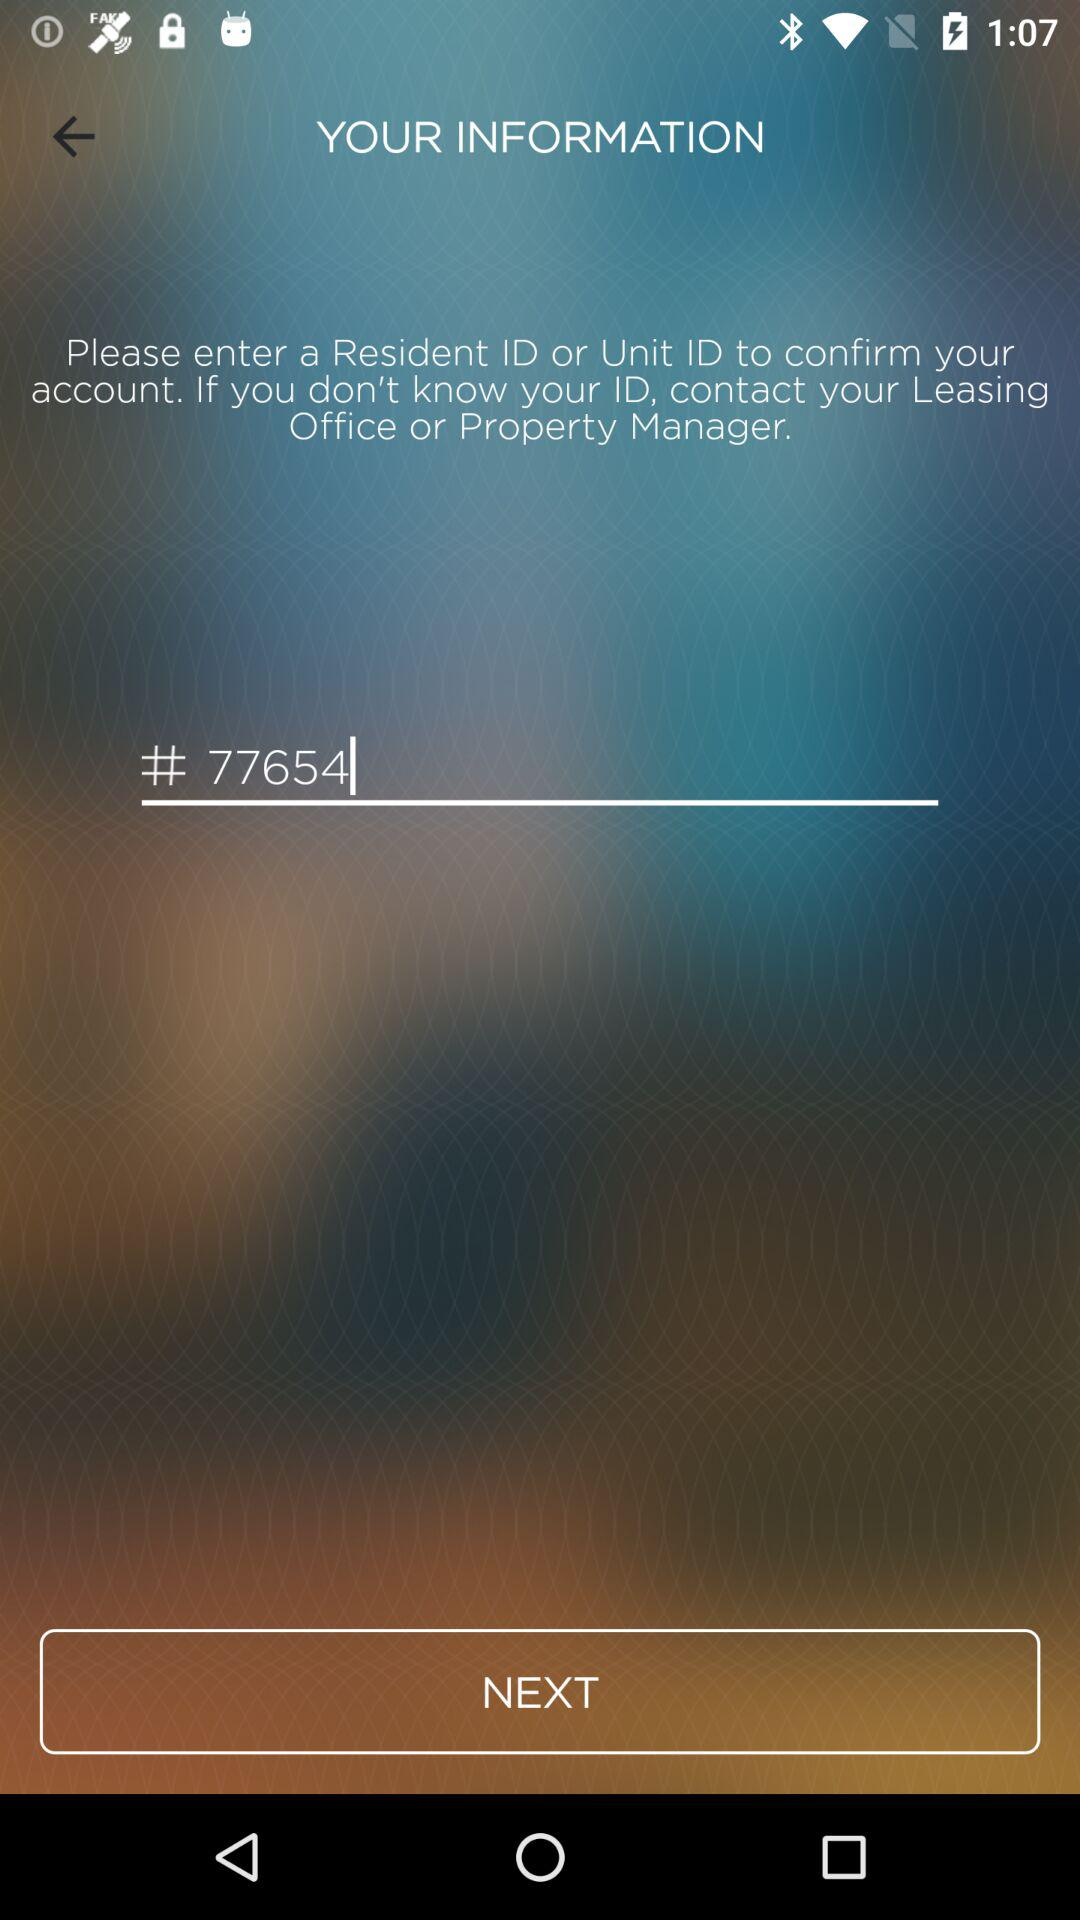What is the resident ID? The resident ID is # 77654. 